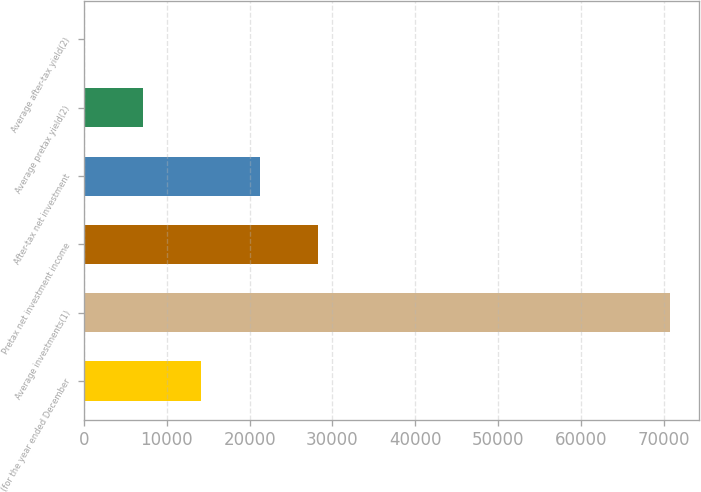Convert chart. <chart><loc_0><loc_0><loc_500><loc_500><bar_chart><fcel>(for the year ended December<fcel>Average investments(1)<fcel>Pretax net investment income<fcel>After-tax net investment<fcel>Average pretax yield(2)<fcel>Average after-tax yield(2)<nl><fcel>14141.9<fcel>70697<fcel>28280.7<fcel>21211.3<fcel>7072.49<fcel>3.1<nl></chart> 